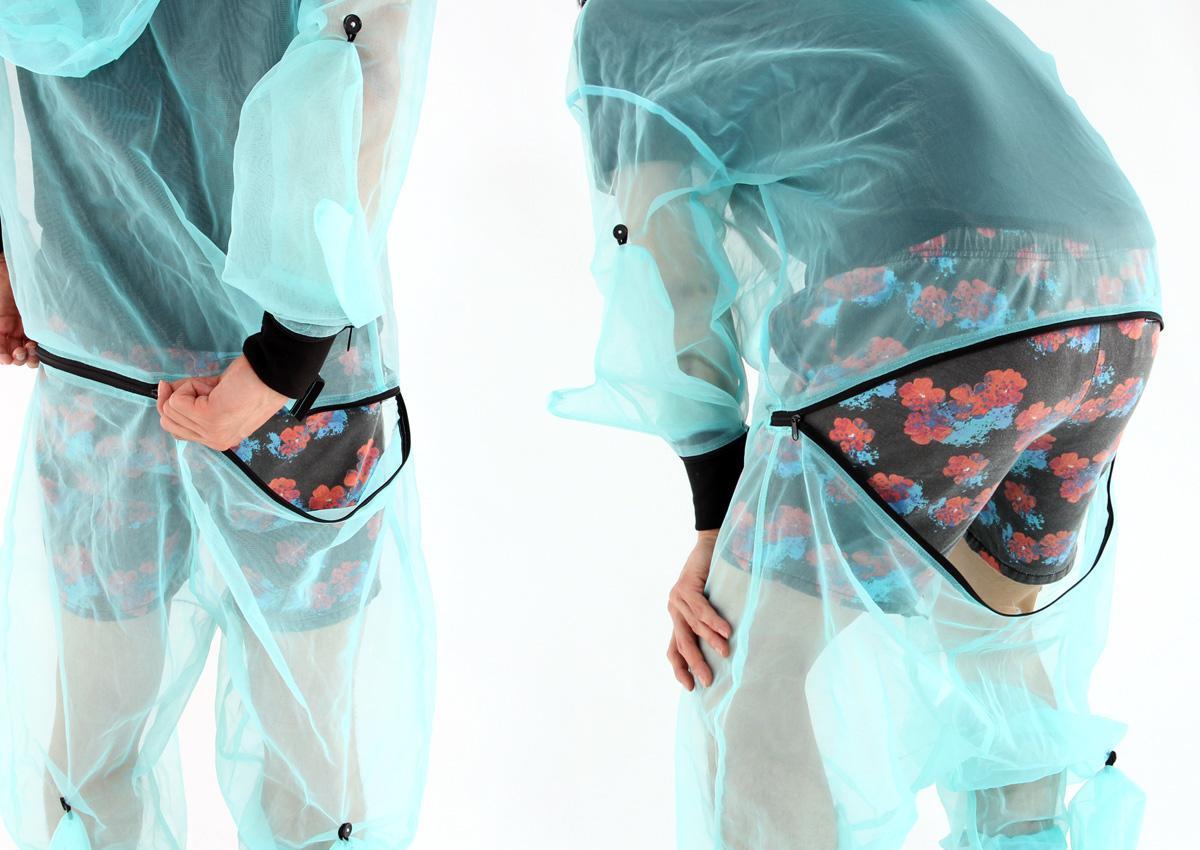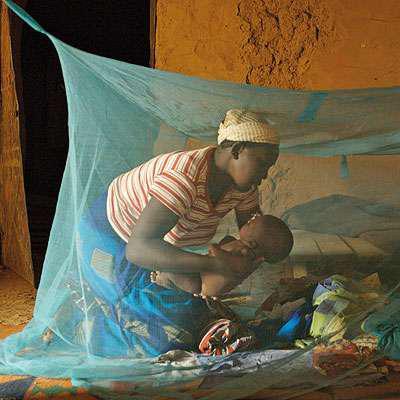The first image is the image on the left, the second image is the image on the right. Assess this claim about the two images: "An image shows a dark-skinned human baby surrounded by netting.". Correct or not? Answer yes or no. Yes. The first image is the image on the left, the second image is the image on the right. Assess this claim about the two images: "A net is set up over a bed in one of the images.". Correct or not? Answer yes or no. Yes. 